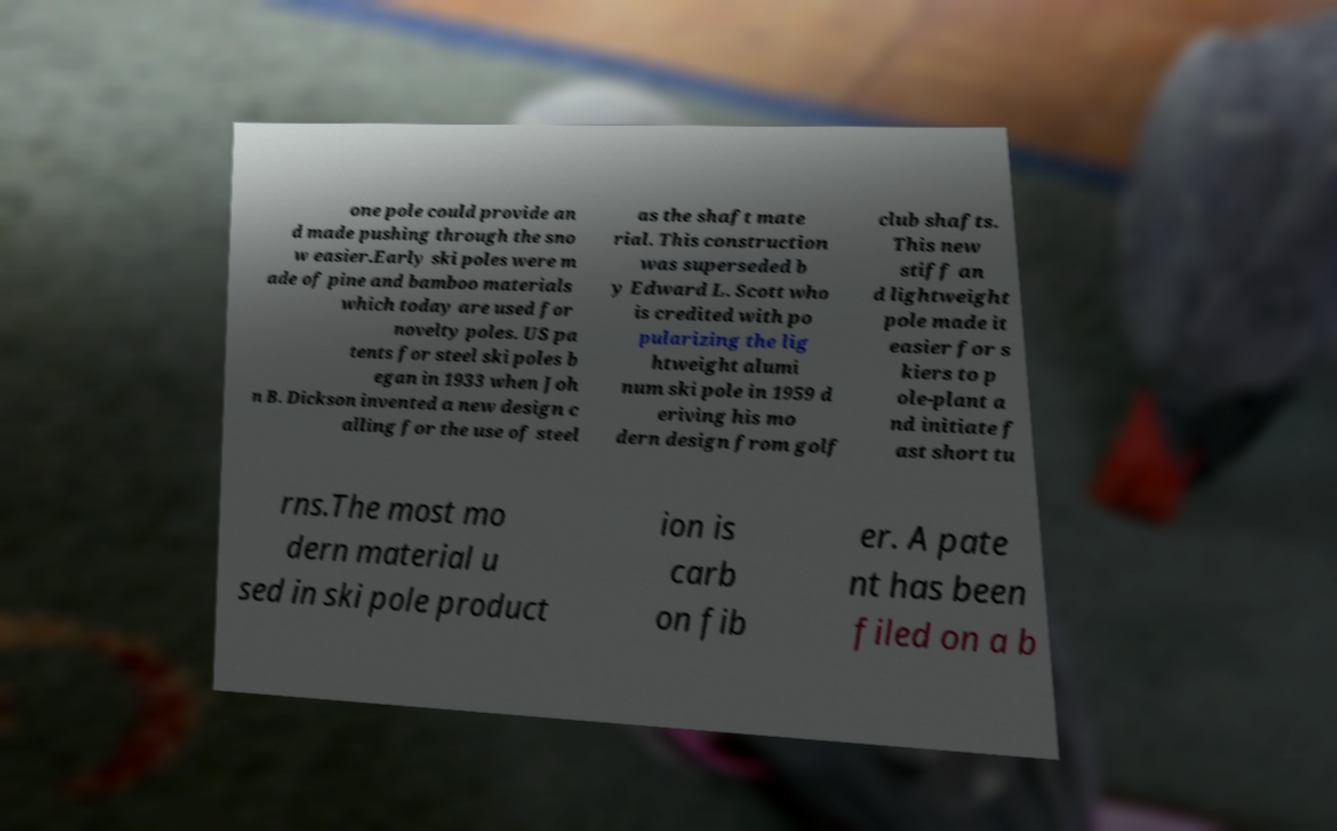Could you assist in decoding the text presented in this image and type it out clearly? one pole could provide an d made pushing through the sno w easier.Early ski poles were m ade of pine and bamboo materials which today are used for novelty poles. US pa tents for steel ski poles b egan in 1933 when Joh n B. Dickson invented a new design c alling for the use of steel as the shaft mate rial. This construction was superseded b y Edward L. Scott who is credited with po pularizing the lig htweight alumi num ski pole in 1959 d eriving his mo dern design from golf club shafts. This new stiff an d lightweight pole made it easier for s kiers to p ole-plant a nd initiate f ast short tu rns.The most mo dern material u sed in ski pole product ion is carb on fib er. A pate nt has been filed on a b 